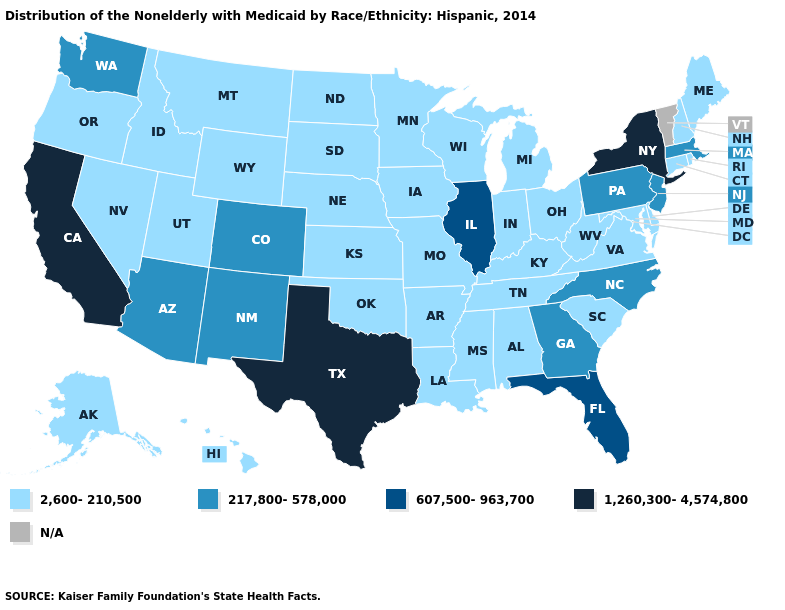Name the states that have a value in the range 2,600-210,500?
Give a very brief answer. Alabama, Alaska, Arkansas, Connecticut, Delaware, Hawaii, Idaho, Indiana, Iowa, Kansas, Kentucky, Louisiana, Maine, Maryland, Michigan, Minnesota, Mississippi, Missouri, Montana, Nebraska, Nevada, New Hampshire, North Dakota, Ohio, Oklahoma, Oregon, Rhode Island, South Carolina, South Dakota, Tennessee, Utah, Virginia, West Virginia, Wisconsin, Wyoming. What is the value of Washington?
Short answer required. 217,800-578,000. What is the value of Kansas?
Answer briefly. 2,600-210,500. Among the states that border North Carolina , which have the lowest value?
Quick response, please. South Carolina, Tennessee, Virginia. Does the first symbol in the legend represent the smallest category?
Be succinct. Yes. Does North Dakota have the lowest value in the MidWest?
Answer briefly. Yes. What is the value of Missouri?
Short answer required. 2,600-210,500. What is the value of North Carolina?
Write a very short answer. 217,800-578,000. What is the lowest value in states that border Ohio?
Answer briefly. 2,600-210,500. Name the states that have a value in the range 2,600-210,500?
Answer briefly. Alabama, Alaska, Arkansas, Connecticut, Delaware, Hawaii, Idaho, Indiana, Iowa, Kansas, Kentucky, Louisiana, Maine, Maryland, Michigan, Minnesota, Mississippi, Missouri, Montana, Nebraska, Nevada, New Hampshire, North Dakota, Ohio, Oklahoma, Oregon, Rhode Island, South Carolina, South Dakota, Tennessee, Utah, Virginia, West Virginia, Wisconsin, Wyoming. Which states hav the highest value in the West?
Answer briefly. California. Name the states that have a value in the range 1,260,300-4,574,800?
Be succinct. California, New York, Texas. Name the states that have a value in the range 2,600-210,500?
Concise answer only. Alabama, Alaska, Arkansas, Connecticut, Delaware, Hawaii, Idaho, Indiana, Iowa, Kansas, Kentucky, Louisiana, Maine, Maryland, Michigan, Minnesota, Mississippi, Missouri, Montana, Nebraska, Nevada, New Hampshire, North Dakota, Ohio, Oklahoma, Oregon, Rhode Island, South Carolina, South Dakota, Tennessee, Utah, Virginia, West Virginia, Wisconsin, Wyoming. Name the states that have a value in the range 2,600-210,500?
Write a very short answer. Alabama, Alaska, Arkansas, Connecticut, Delaware, Hawaii, Idaho, Indiana, Iowa, Kansas, Kentucky, Louisiana, Maine, Maryland, Michigan, Minnesota, Mississippi, Missouri, Montana, Nebraska, Nevada, New Hampshire, North Dakota, Ohio, Oklahoma, Oregon, Rhode Island, South Carolina, South Dakota, Tennessee, Utah, Virginia, West Virginia, Wisconsin, Wyoming. 